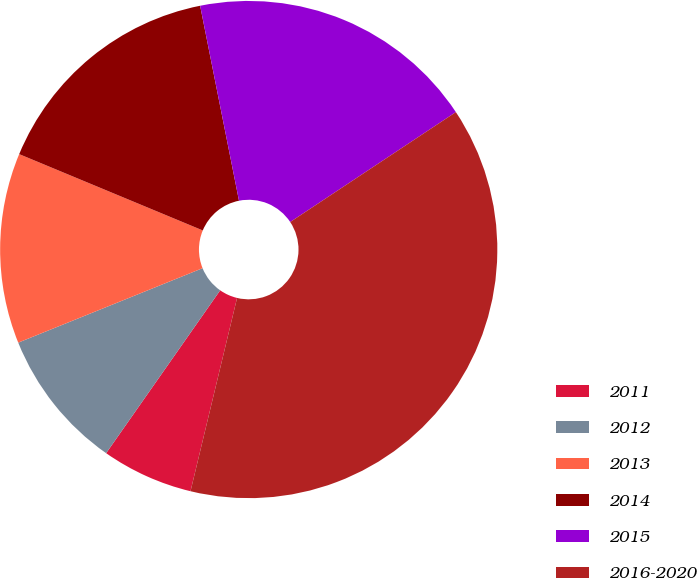Convert chart to OTSL. <chart><loc_0><loc_0><loc_500><loc_500><pie_chart><fcel>2011<fcel>2012<fcel>2013<fcel>2014<fcel>2015<fcel>2016-2020<nl><fcel>5.96%<fcel>9.17%<fcel>12.38%<fcel>15.6%<fcel>18.81%<fcel>38.09%<nl></chart> 